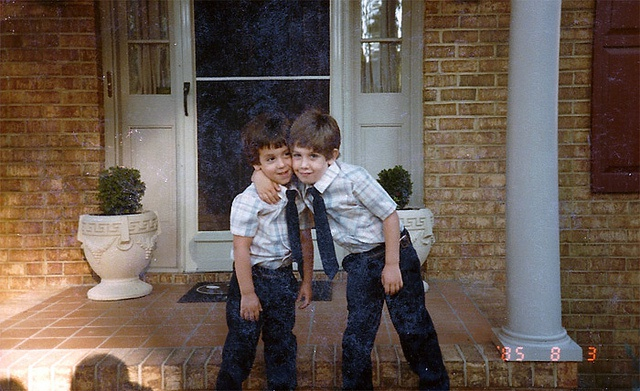Describe the objects in this image and their specific colors. I can see people in maroon, black, darkgray, gray, and lavender tones, people in maroon, black, gray, and darkgray tones, potted plant in maroon, darkgray, tan, black, and lightgray tones, potted plant in maroon, darkgray, black, and gray tones, and tie in maroon, black, navy, darkblue, and gray tones in this image. 